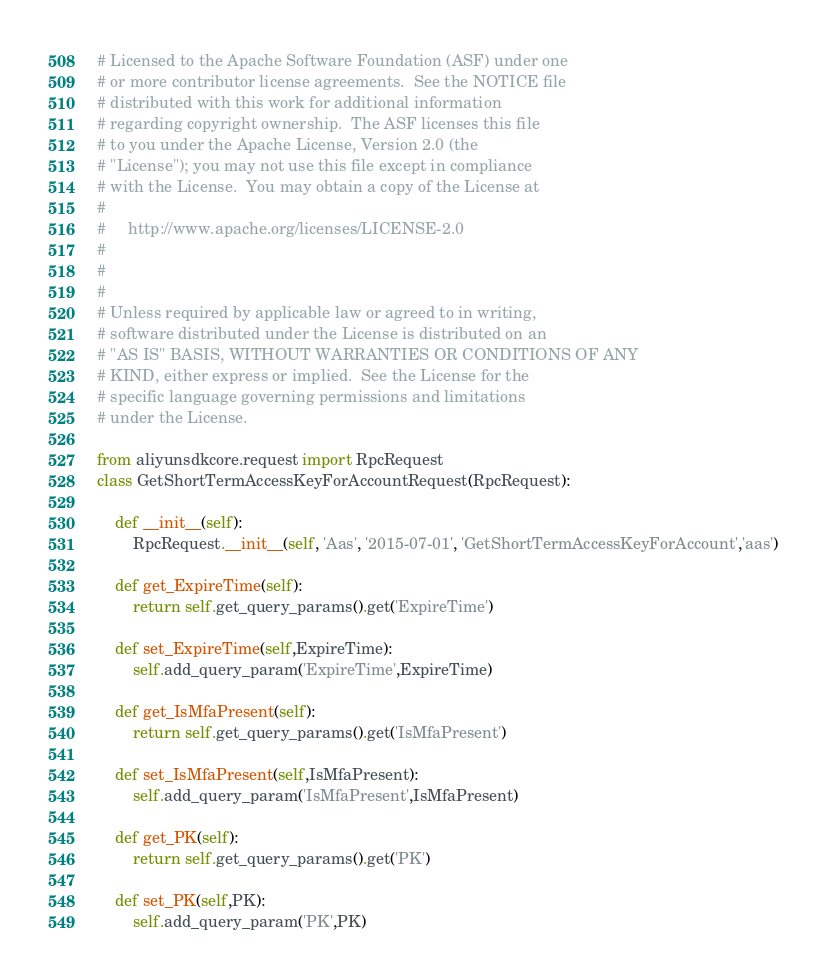<code> <loc_0><loc_0><loc_500><loc_500><_Python_># Licensed to the Apache Software Foundation (ASF) under one
# or more contributor license agreements.  See the NOTICE file
# distributed with this work for additional information
# regarding copyright ownership.  The ASF licenses this file
# to you under the Apache License, Version 2.0 (the
# "License"); you may not use this file except in compliance
# with the License.  You may obtain a copy of the License at
#
#     http://www.apache.org/licenses/LICENSE-2.0
#
#
#
# Unless required by applicable law or agreed to in writing,
# software distributed under the License is distributed on an
# "AS IS" BASIS, WITHOUT WARRANTIES OR CONDITIONS OF ANY
# KIND, either express or implied.  See the License for the
# specific language governing permissions and limitations
# under the License.

from aliyunsdkcore.request import RpcRequest
class GetShortTermAccessKeyForAccountRequest(RpcRequest):

	def __init__(self):
		RpcRequest.__init__(self, 'Aas', '2015-07-01', 'GetShortTermAccessKeyForAccount','aas')

	def get_ExpireTime(self):
		return self.get_query_params().get('ExpireTime')

	def set_ExpireTime(self,ExpireTime):
		self.add_query_param('ExpireTime',ExpireTime)

	def get_IsMfaPresent(self):
		return self.get_query_params().get('IsMfaPresent')

	def set_IsMfaPresent(self,IsMfaPresent):
		self.add_query_param('IsMfaPresent',IsMfaPresent)

	def get_PK(self):
		return self.get_query_params().get('PK')

	def set_PK(self,PK):
		self.add_query_param('PK',PK)</code> 